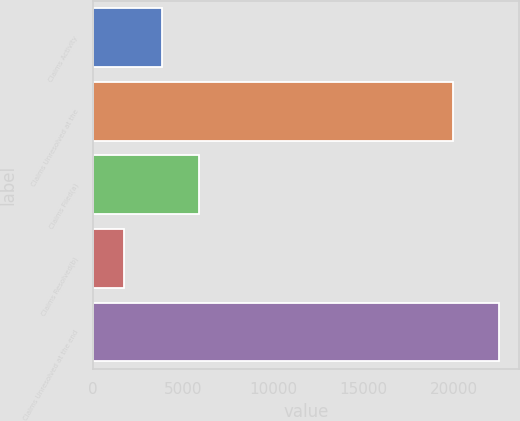Convert chart to OTSL. <chart><loc_0><loc_0><loc_500><loc_500><bar_chart><fcel>Claims Activity<fcel>Claims Unresolved at the<fcel>Claims Filed(a)<fcel>Claims Resolved(b)<fcel>Claims Unresolved at the end<nl><fcel>3833.8<fcel>19940<fcel>5905.6<fcel>1762<fcel>22480<nl></chart> 